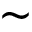<formula> <loc_0><loc_0><loc_500><loc_500>\sim</formula> 